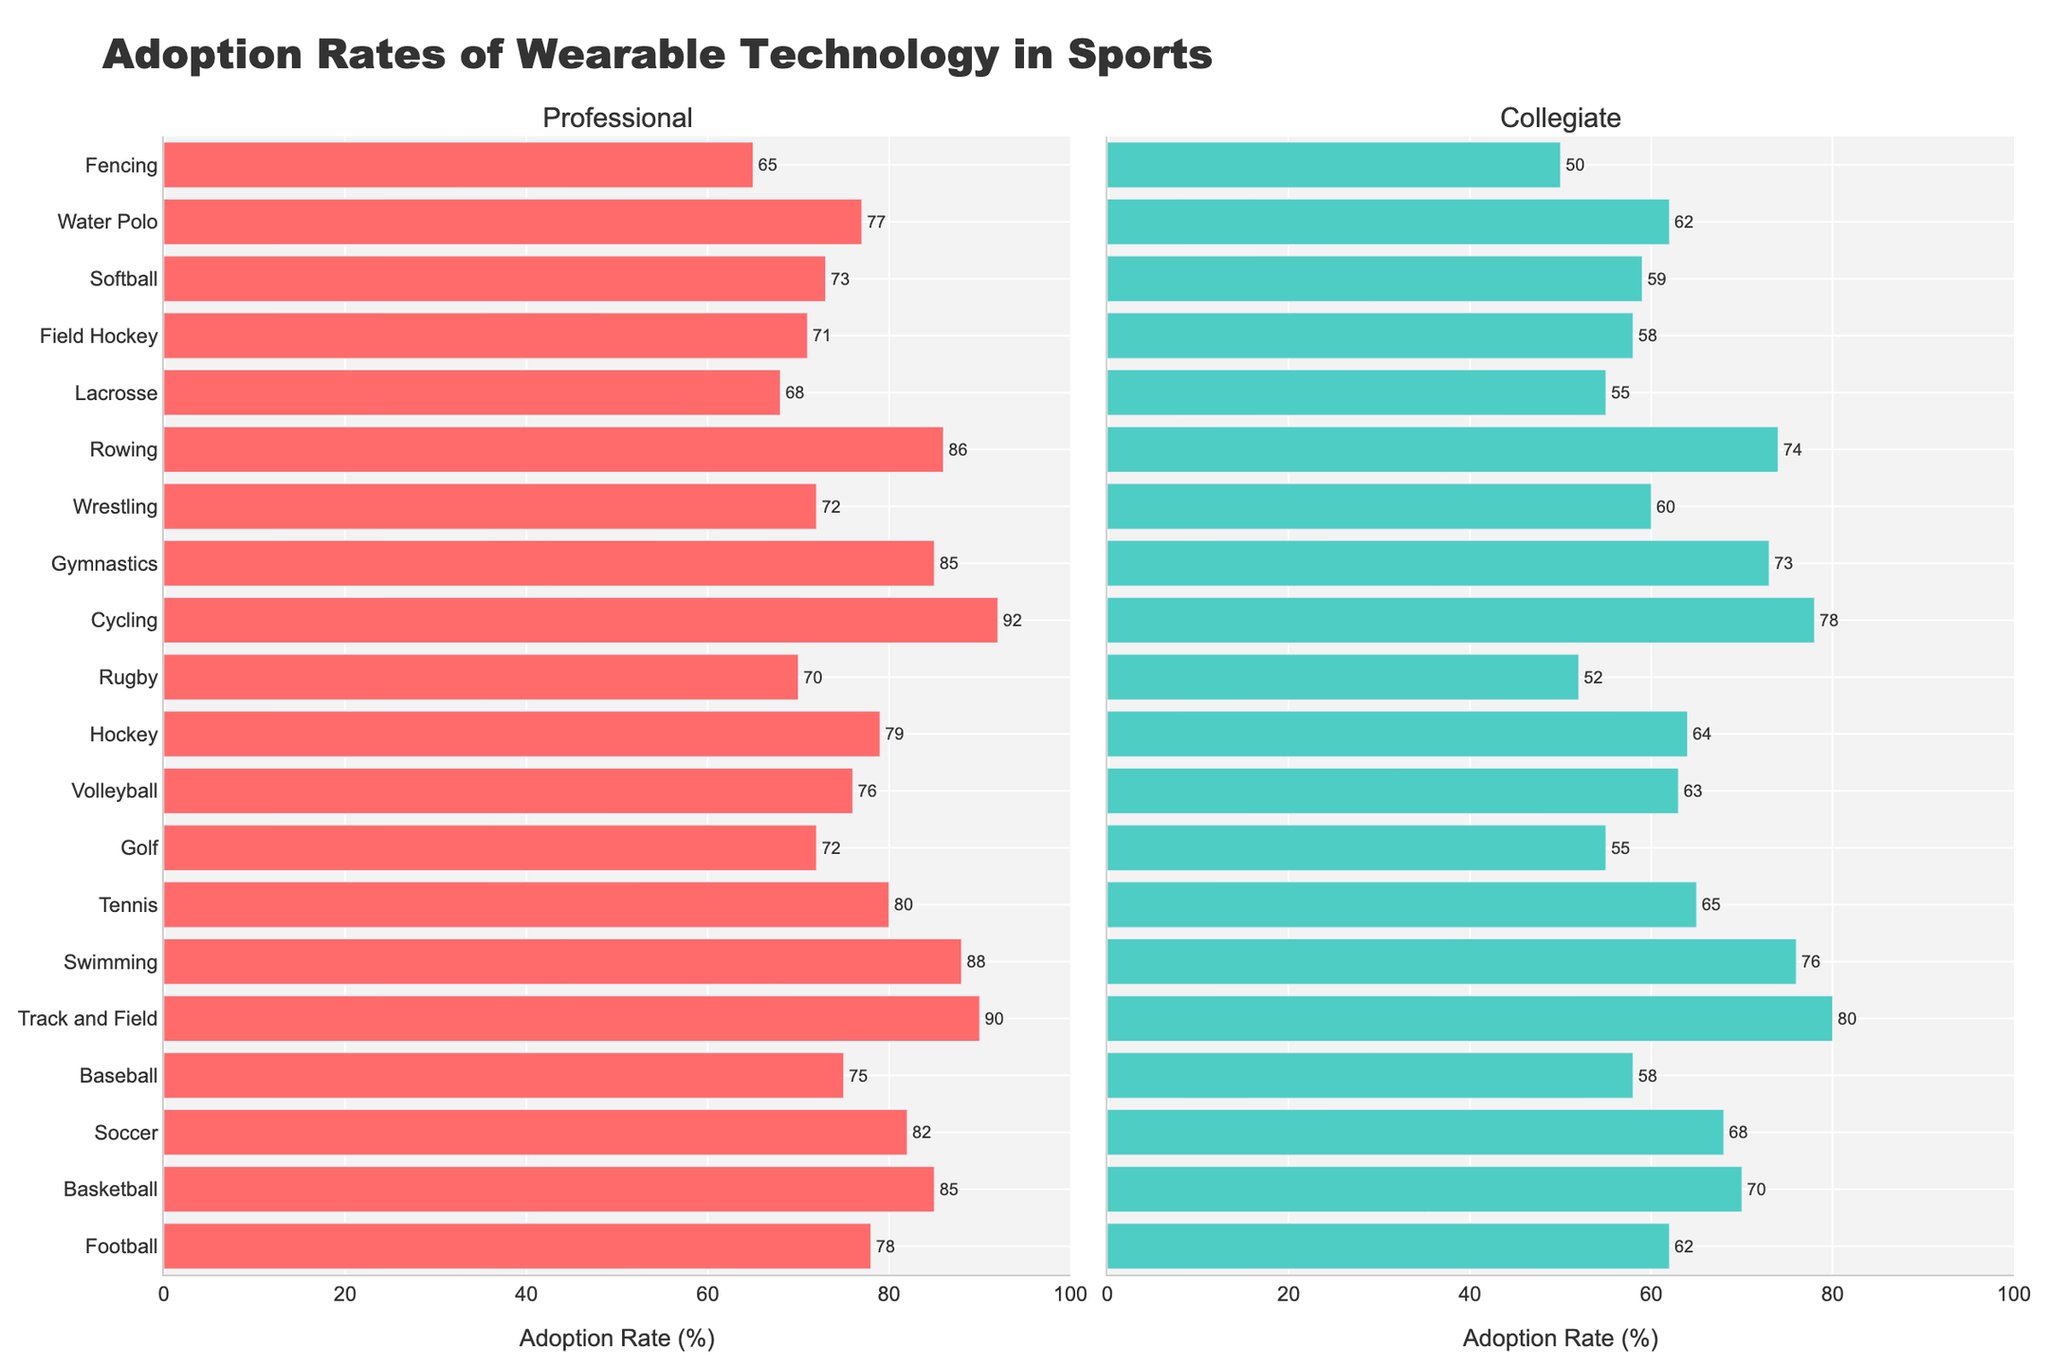What sport has the highest adoption rate of wearable technology at the professional level? Track and Field has the highest adoption rate in this category as indicated by the highest bar in the "Professional" subplot.
Answer: Track and Field Which sport sees the greatest difference in adoption rates between the professional and collegiate levels? Cycling shows the greatest difference, with a professional adoption rate of 92% and a collegiate rate of 78%, resulting in a difference of 14%.
Answer: Cycling How does the adoption rate of wearable technology in Rugby at the collegiate level compare with Football at the professional level? Rugby at the collegiate level has an adoption rate of 52%, while Football at the professional level has an adoption rate of 78%. Football at the professional level has a higher adoption rate.
Answer: Football at the professional level What is the average adoption rate of wearable technology across all sports at the collegiate level? Sum all adoption rates at the collegiate level (1289) and divide by the number of sports (20). The resulting average is 64.45.
Answer: 64.45 Which sports have an equal adoption rate of wearable technology at the professional level? Both Gymnastics and Basketball have an equal adoption rate of 85% at the professional level, as indicated by the length of their respective bars.
Answer: Gymnastics and Basketball Is the adoption rate in Swimming higher at the collegiate or professional level? Professional Swimming has an adoption rate of 88%, while Collegiate Swimming has an adoption rate of 76%. It is higher at the professional level.
Answer: Professional level What is the total adoption rate of wearable technology for Volleyball at both professional and collegiate levels? The adoption rate for Professional Volleyball is 76% and for Collegiate Volleyball is 63%. The total is 76 + 63 = 139.
Answer: 139 Which sport has the lowest collegiate adoption rate of wearable technology? Fencing has the lowest collegiate adoption rate of 50%, as shown by the shortest bar in the "Collegiate" subplot.
Answer: Fencing 